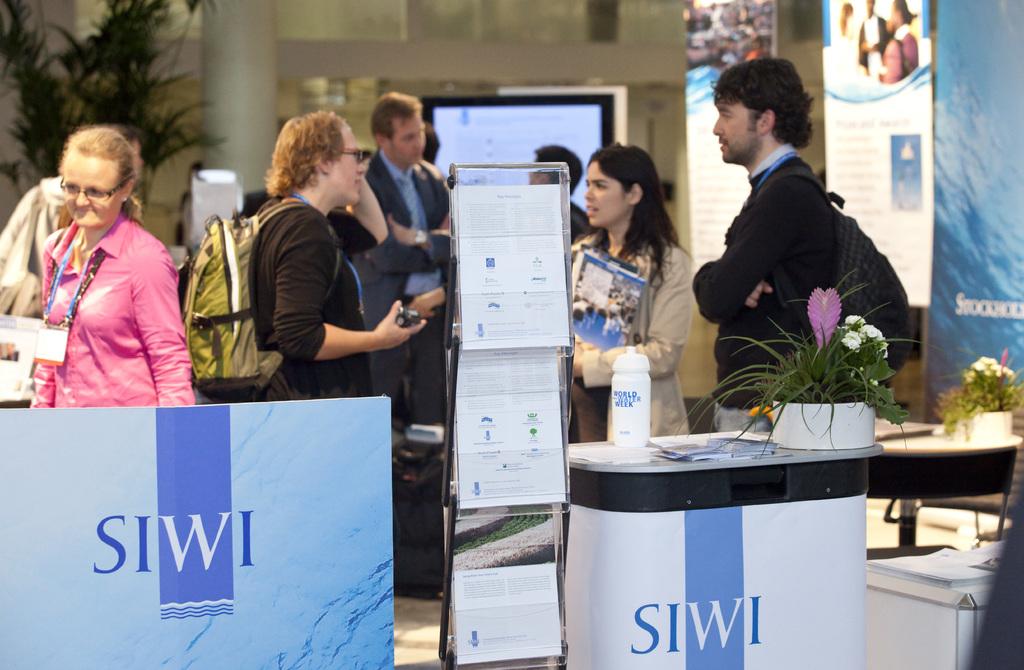What is the company being promoted?
Offer a terse response. Siwi. What letter is in white?
Offer a terse response. W. 